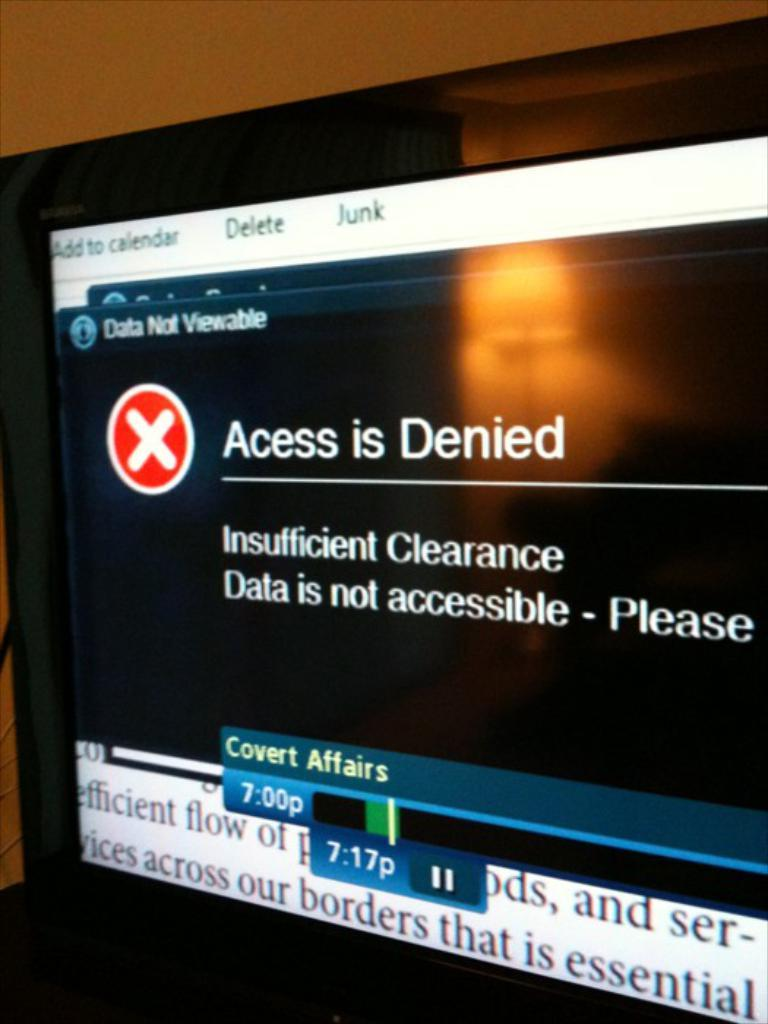<image>
Provide a brief description of the given image. scrren showing a red and white x and access is denied message with the reason underneath 